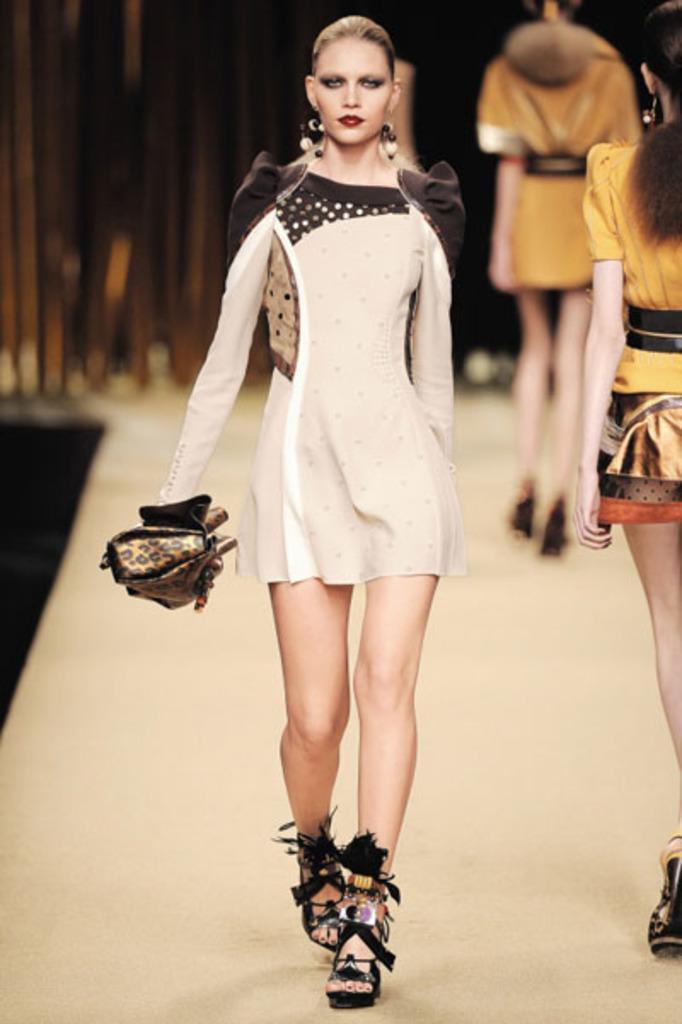Could you give a brief overview of what you see in this image? In the center of the image we can see one woman walking on the ramp. And we can see she is in a different costume and she is holding a bag. In the background we can see curtains, two persons are walking and a few other objects. 